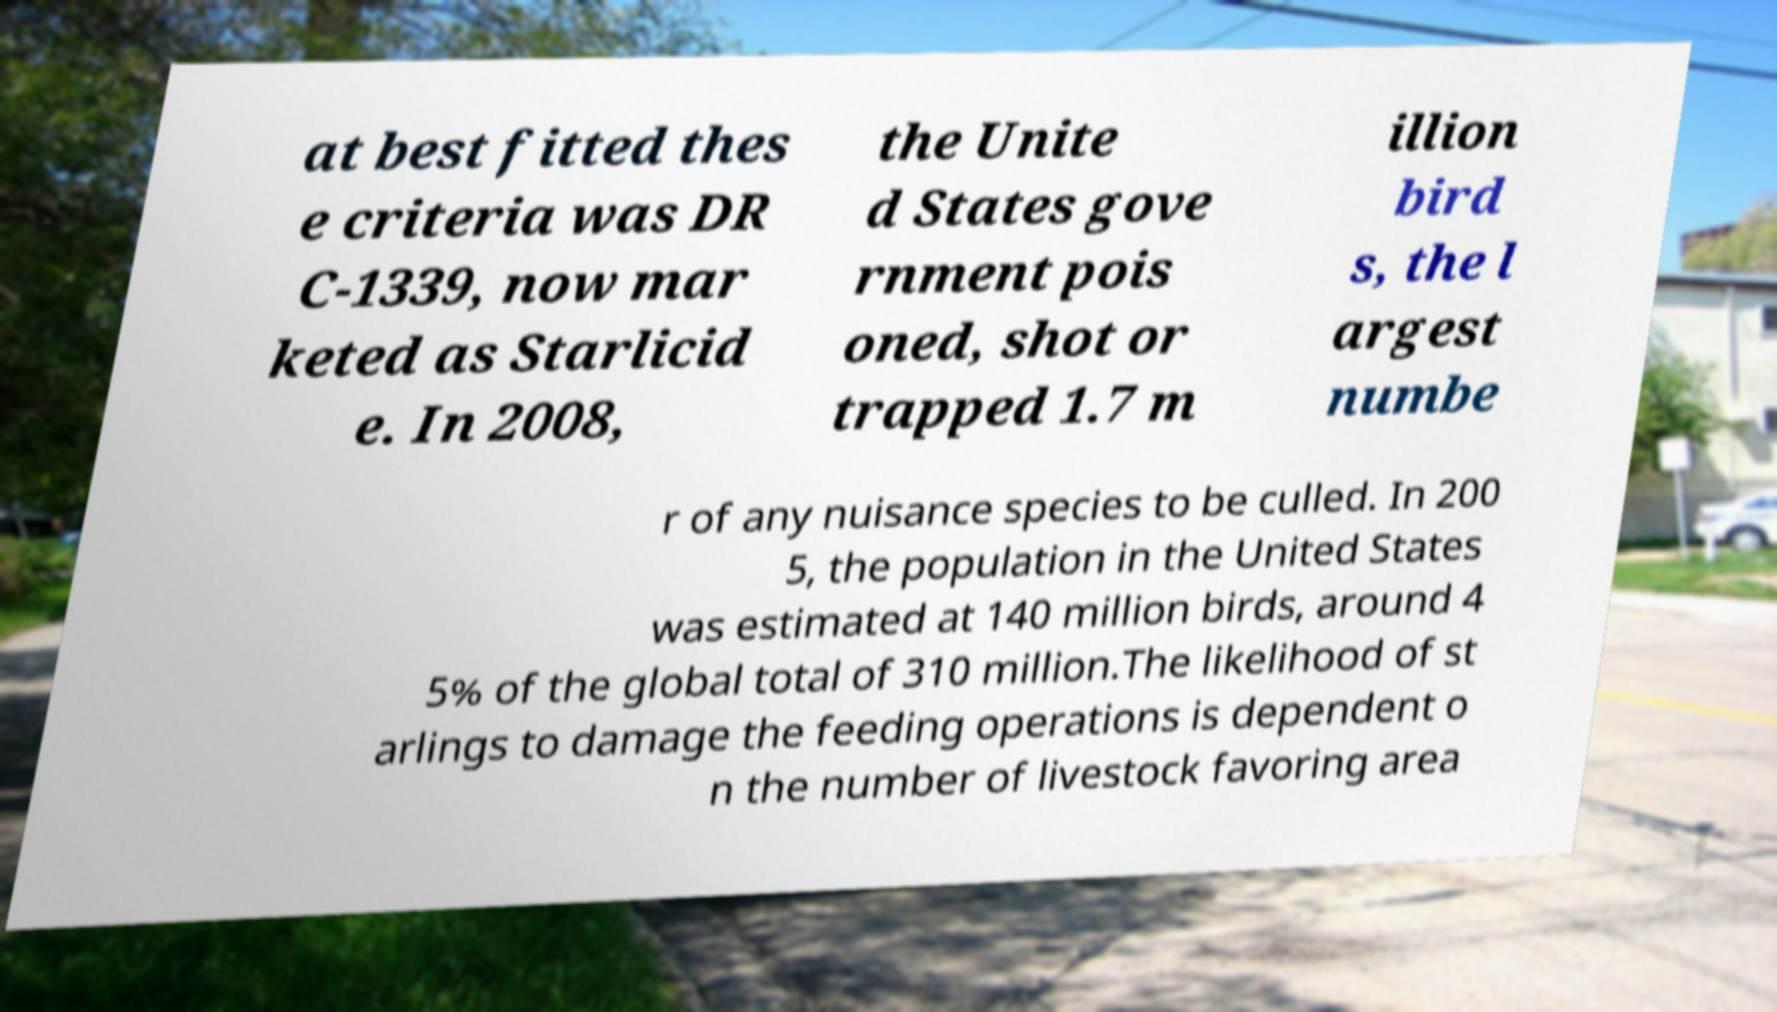Could you assist in decoding the text presented in this image and type it out clearly? at best fitted thes e criteria was DR C-1339, now mar keted as Starlicid e. In 2008, the Unite d States gove rnment pois oned, shot or trapped 1.7 m illion bird s, the l argest numbe r of any nuisance species to be culled. In 200 5, the population in the United States was estimated at 140 million birds, around 4 5% of the global total of 310 million.The likelihood of st arlings to damage the feeding operations is dependent o n the number of livestock favoring area 